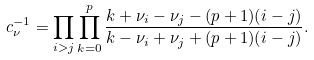Convert formula to latex. <formula><loc_0><loc_0><loc_500><loc_500>c _ { \nu } ^ { - 1 } = \prod _ { i > j } \prod _ { k = 0 } ^ { p } \frac { k + \nu _ { i } - \nu _ { j } - ( p + 1 ) ( i - j ) } { k - \nu _ { i } + \nu _ { j } + ( p + 1 ) ( i - j ) } .</formula> 